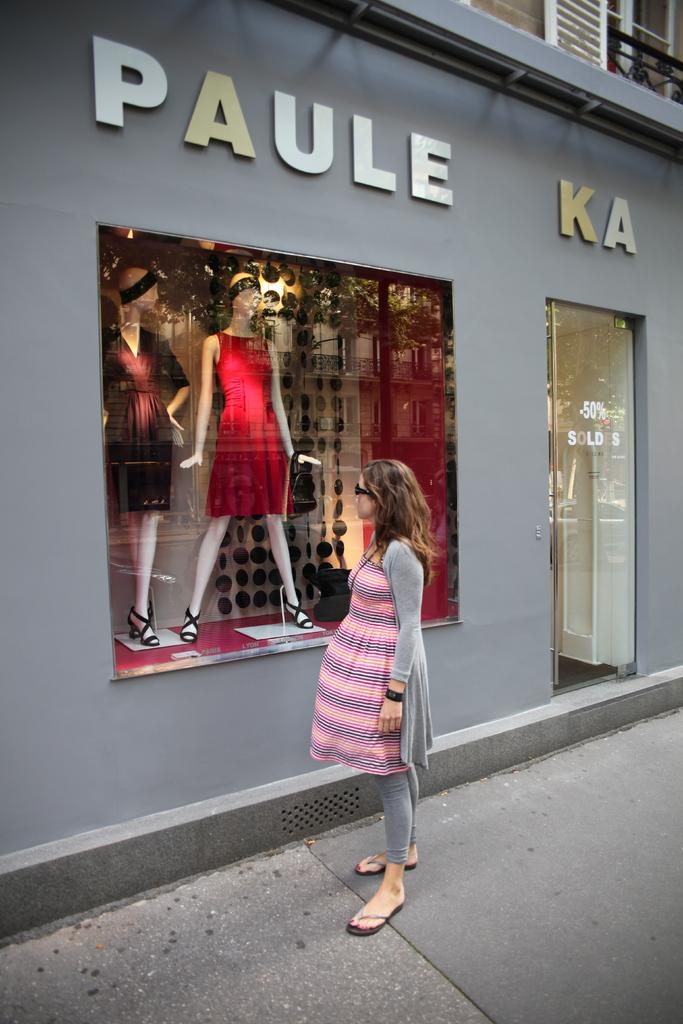What is the woman doing in the image? The woman is standing on a pathway in the image. What is in front of the woman? There is a shop in front of the woman. What can be seen on the shop? The shop has a name board and a glass door. What is visible through the glass window of the shop? Mannequins are visible through the glass window of the shop. Can you see any nests in the image? There are no nests visible in the image. What type of corn is being sold in the shop? There is no corn being sold in the shop, as the image only shows mannequins visible through the glass window. 